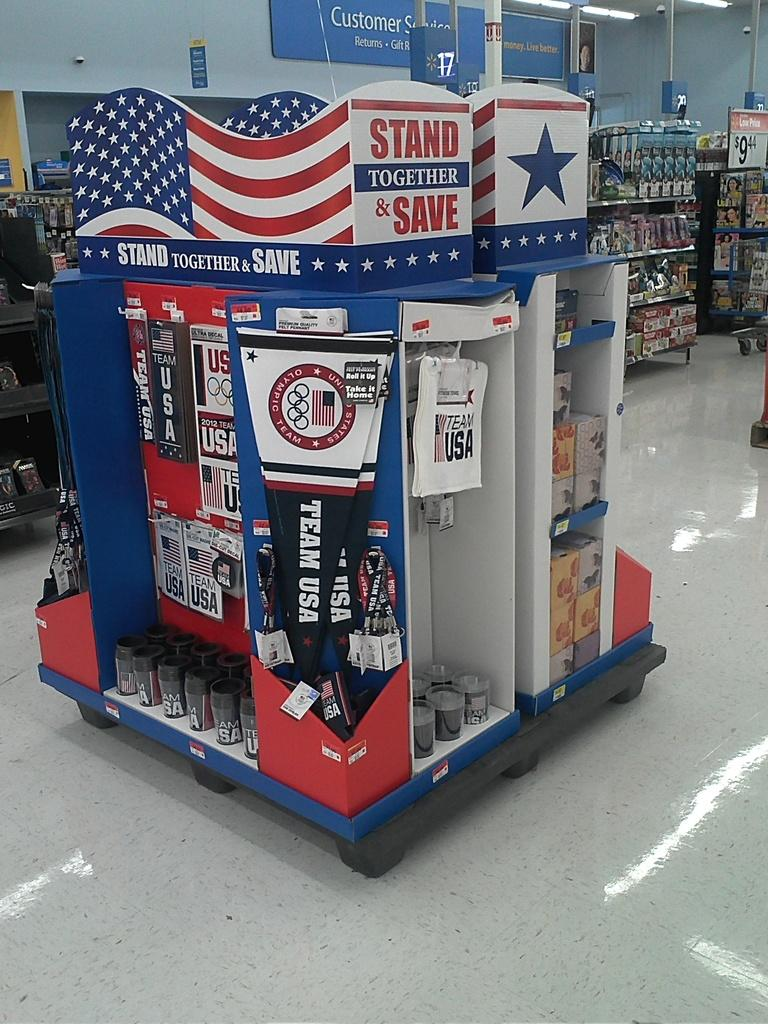<image>
Describe the image concisely. A stand in a store which has the words Stand Together and Save at the top. 